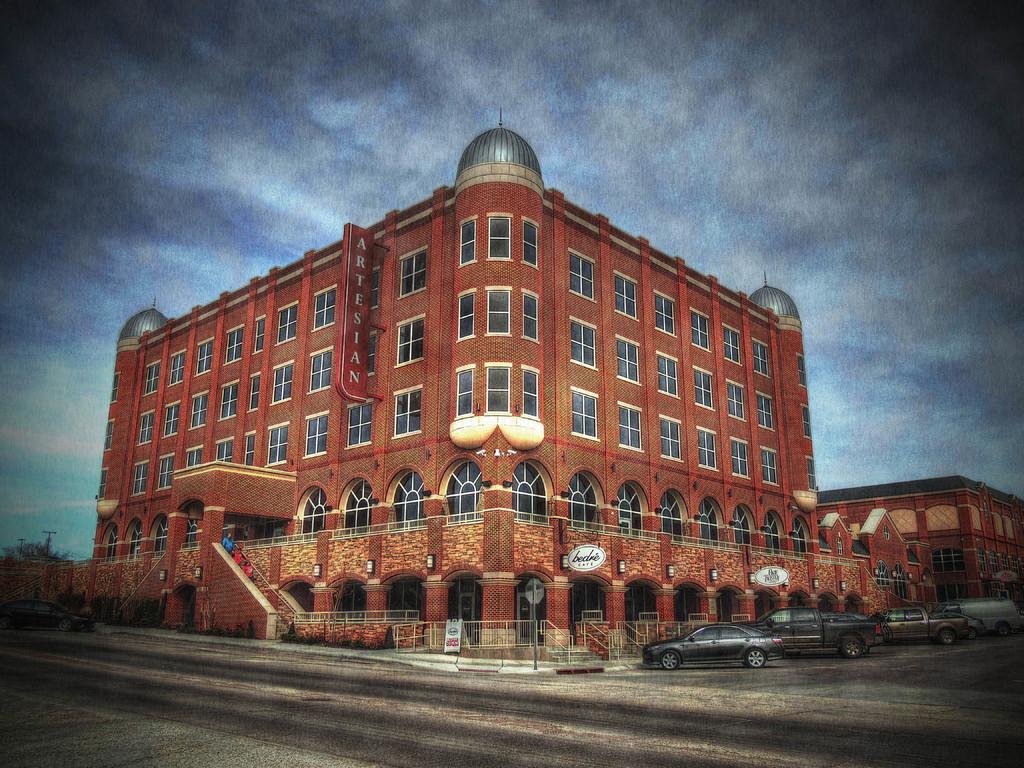Could you give a brief overview of what you see in this image? In this there is a building in the middle. At the top there is the sky. At the bottom there is a road on which there are few cars parked. Beside the cars there is a fence. 